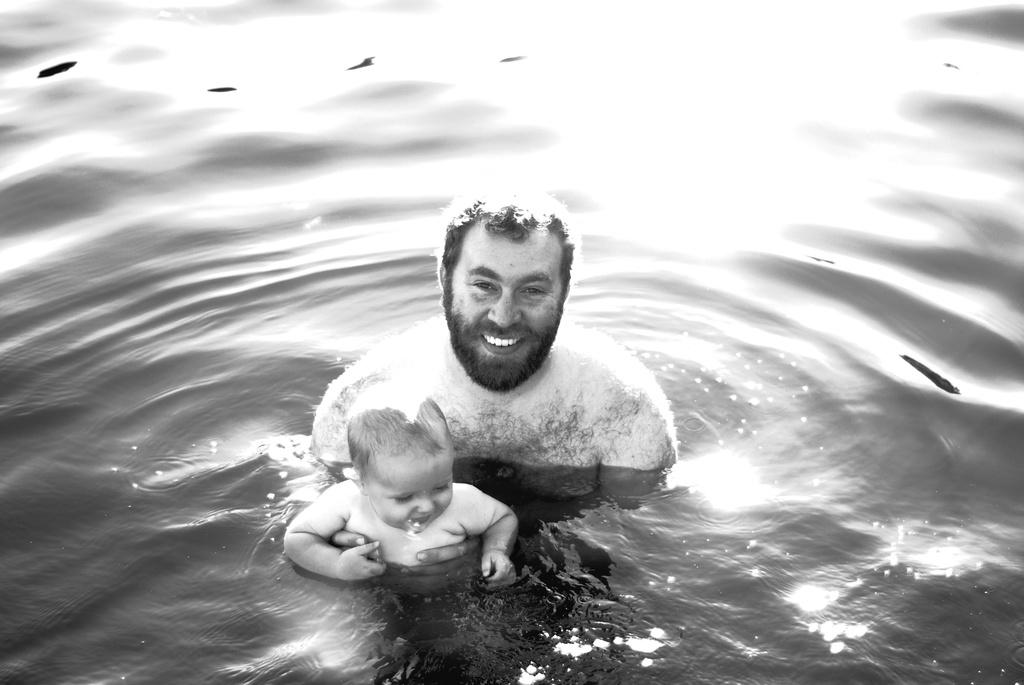What is the man in the image doing? There is a man in the water in the image. How does the man appear to feel in the image? The man has a smiling face. What is the man holding in the image? The man is holding a baby. What type of selection process is taking place in the image? There is no selection process present in the image. Where might this image have been taken, considering the presence of a park? There is no reference to a park in the image, so it cannot be determined from the image alone. 